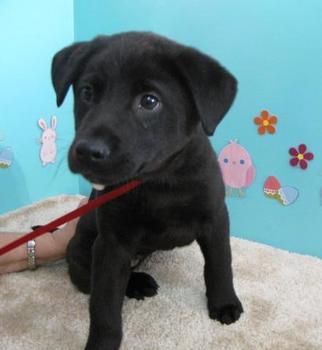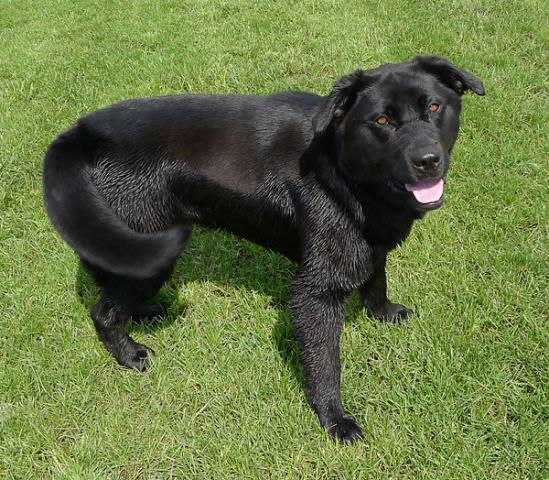The first image is the image on the left, the second image is the image on the right. Examine the images to the left and right. Is the description "The right image contains two dogs that are different colors." accurate? Answer yes or no. No. 